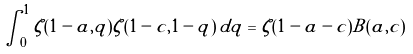<formula> <loc_0><loc_0><loc_500><loc_500>\int _ { 0 } ^ { 1 } \zeta ( 1 - a , q ) \zeta ( 1 - c , 1 - q ) \, d q = \zeta ( 1 - a - c ) B ( a , c )</formula> 